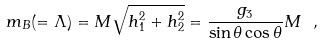Convert formula to latex. <formula><loc_0><loc_0><loc_500><loc_500>m _ { B } ( = \Lambda ) = M \sqrt { h _ { 1 } ^ { 2 } + h _ { 2 } ^ { 2 } } = \frac { g _ { 3 } } { \sin \theta \cos \theta } M \ ,</formula> 